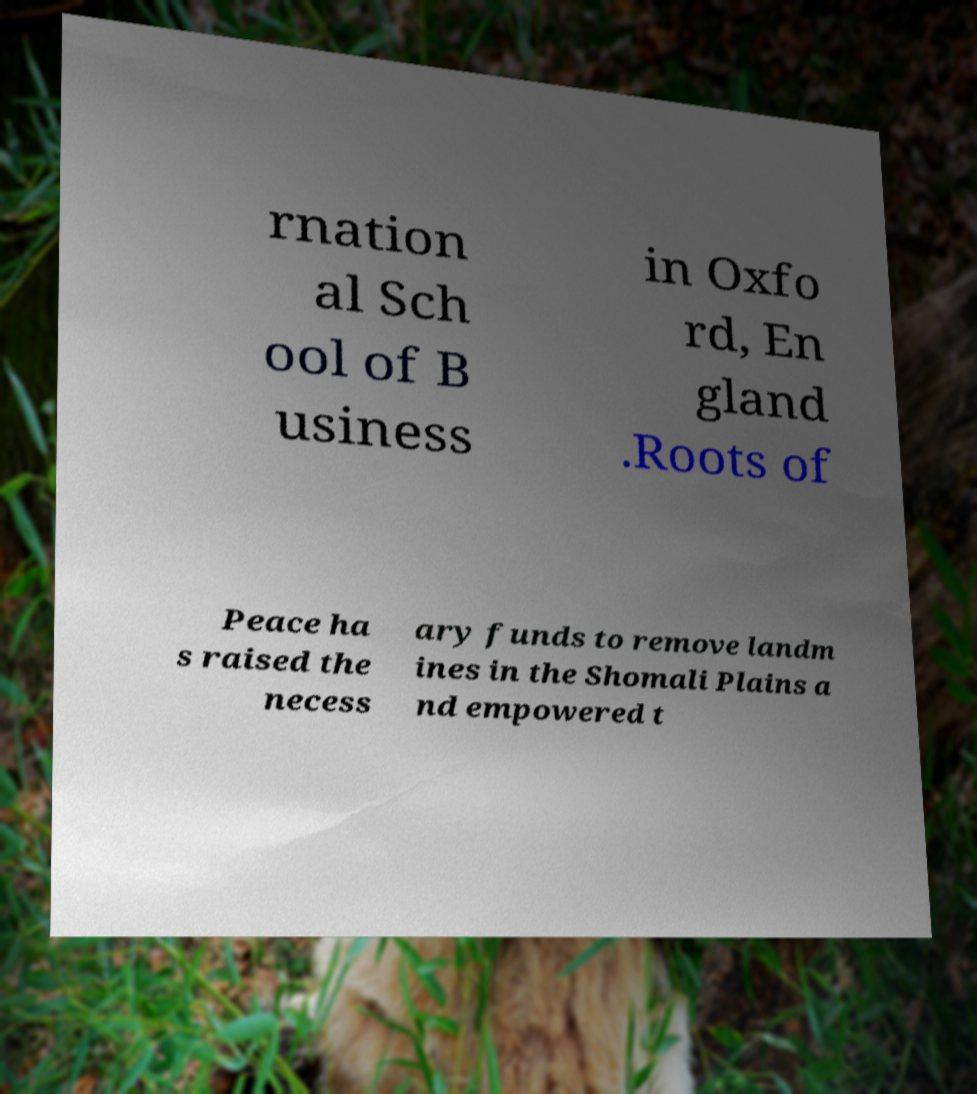Could you extract and type out the text from this image? rnation al Sch ool of B usiness in Oxfo rd, En gland .Roots of Peace ha s raised the necess ary funds to remove landm ines in the Shomali Plains a nd empowered t 